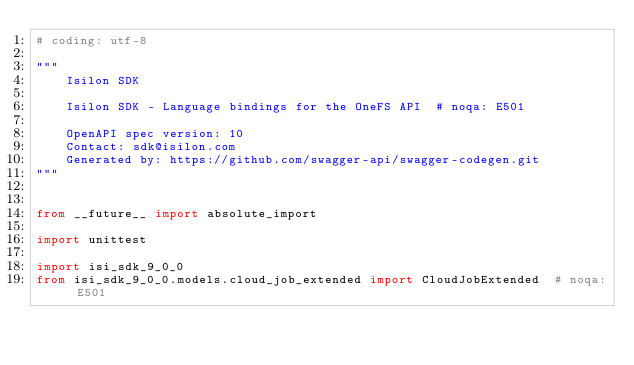<code> <loc_0><loc_0><loc_500><loc_500><_Python_># coding: utf-8

"""
    Isilon SDK

    Isilon SDK - Language bindings for the OneFS API  # noqa: E501

    OpenAPI spec version: 10
    Contact: sdk@isilon.com
    Generated by: https://github.com/swagger-api/swagger-codegen.git
"""


from __future__ import absolute_import

import unittest

import isi_sdk_9_0_0
from isi_sdk_9_0_0.models.cloud_job_extended import CloudJobExtended  # noqa: E501</code> 